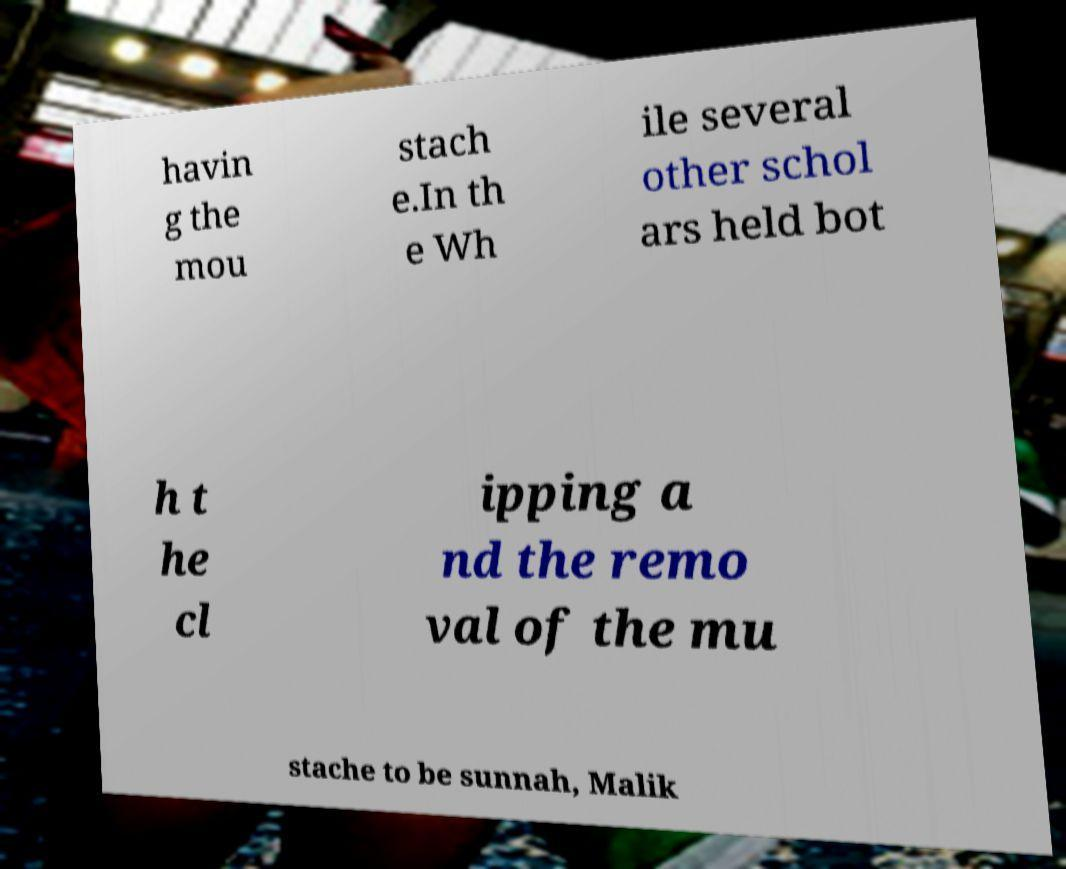Please identify and transcribe the text found in this image. havin g the mou stach e.In th e Wh ile several other schol ars held bot h t he cl ipping a nd the remo val of the mu stache to be sunnah, Malik 